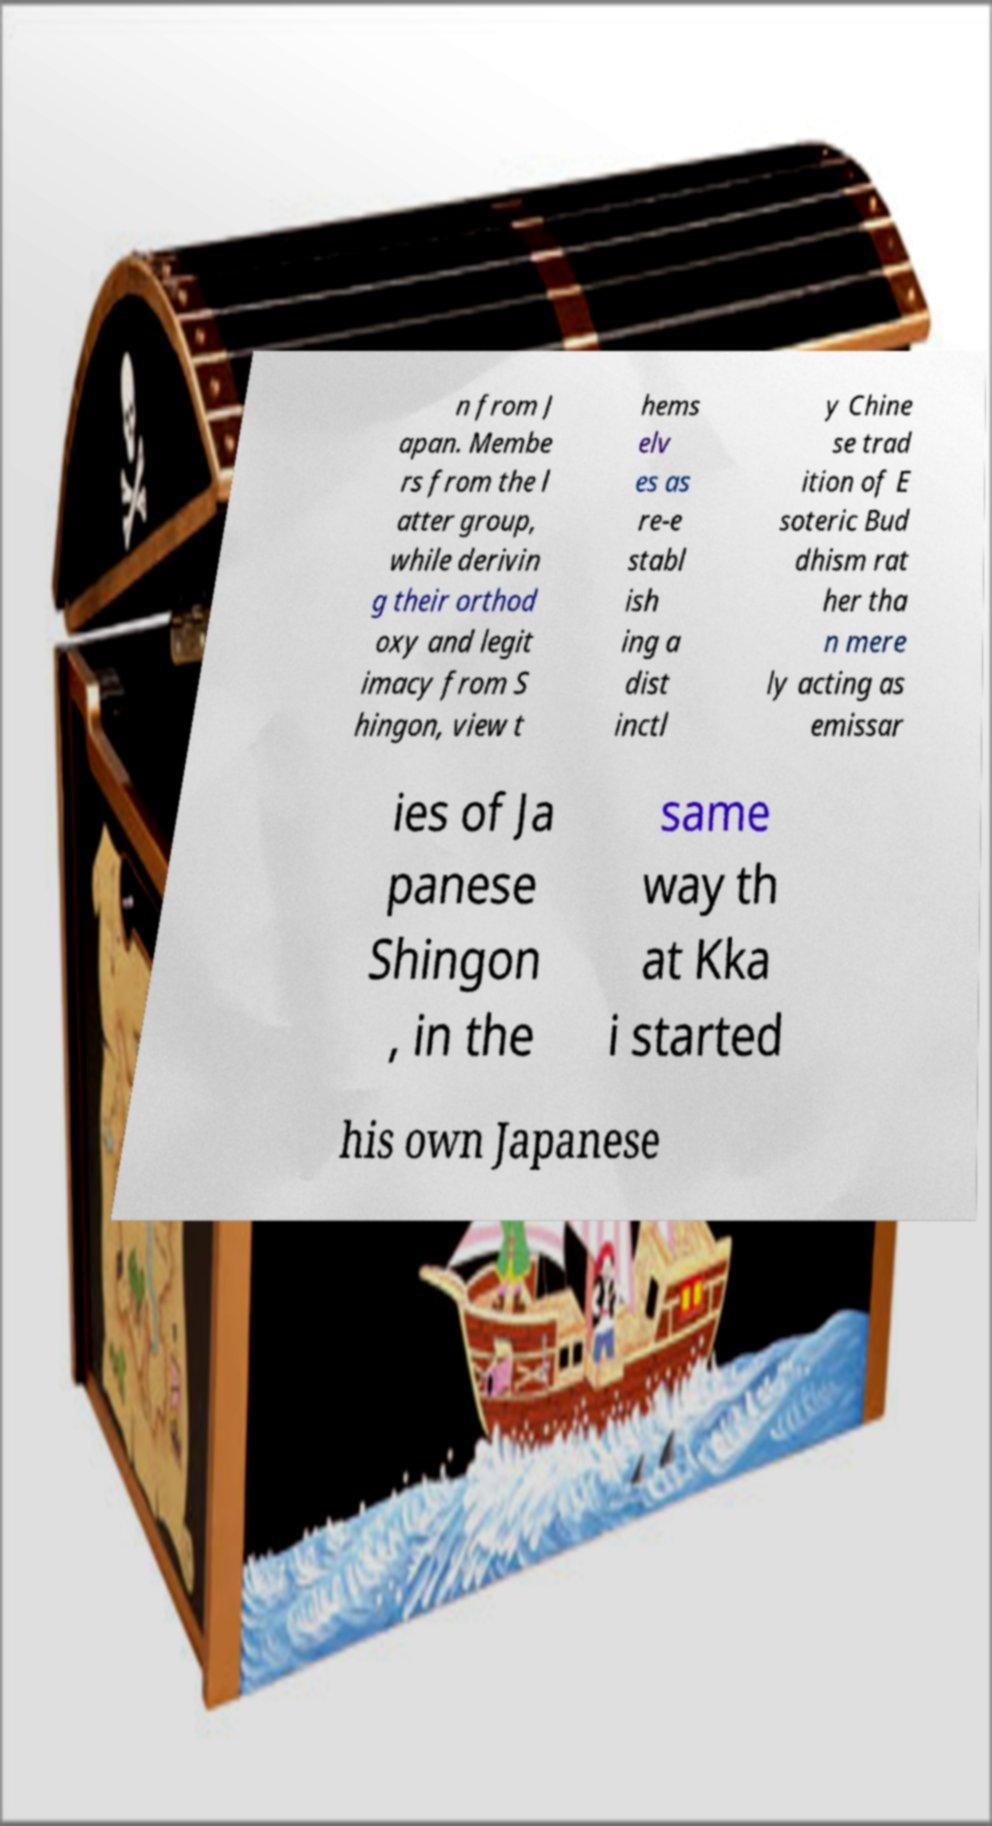Please read and relay the text visible in this image. What does it say? n from J apan. Membe rs from the l atter group, while derivin g their orthod oxy and legit imacy from S hingon, view t hems elv es as re-e stabl ish ing a dist inctl y Chine se trad ition of E soteric Bud dhism rat her tha n mere ly acting as emissar ies of Ja panese Shingon , in the same way th at Kka i started his own Japanese 